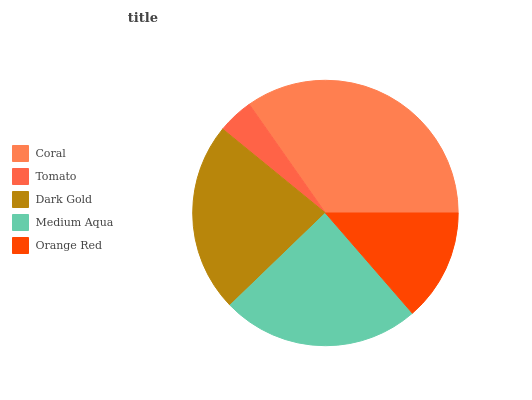Is Tomato the minimum?
Answer yes or no. Yes. Is Coral the maximum?
Answer yes or no. Yes. Is Dark Gold the minimum?
Answer yes or no. No. Is Dark Gold the maximum?
Answer yes or no. No. Is Dark Gold greater than Tomato?
Answer yes or no. Yes. Is Tomato less than Dark Gold?
Answer yes or no. Yes. Is Tomato greater than Dark Gold?
Answer yes or no. No. Is Dark Gold less than Tomato?
Answer yes or no. No. Is Dark Gold the high median?
Answer yes or no. Yes. Is Dark Gold the low median?
Answer yes or no. Yes. Is Orange Red the high median?
Answer yes or no. No. Is Orange Red the low median?
Answer yes or no. No. 